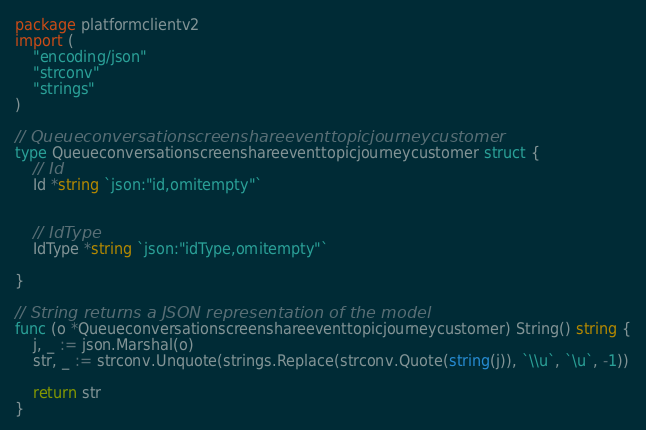<code> <loc_0><loc_0><loc_500><loc_500><_Go_>package platformclientv2
import (
	"encoding/json"
	"strconv"
	"strings"
)

// Queueconversationscreenshareeventtopicjourneycustomer
type Queueconversationscreenshareeventtopicjourneycustomer struct { 
	// Id
	Id *string `json:"id,omitempty"`


	// IdType
	IdType *string `json:"idType,omitempty"`

}

// String returns a JSON representation of the model
func (o *Queueconversationscreenshareeventtopicjourneycustomer) String() string {
	j, _ := json.Marshal(o)
	str, _ := strconv.Unquote(strings.Replace(strconv.Quote(string(j)), `\\u`, `\u`, -1))

	return str
}
</code> 